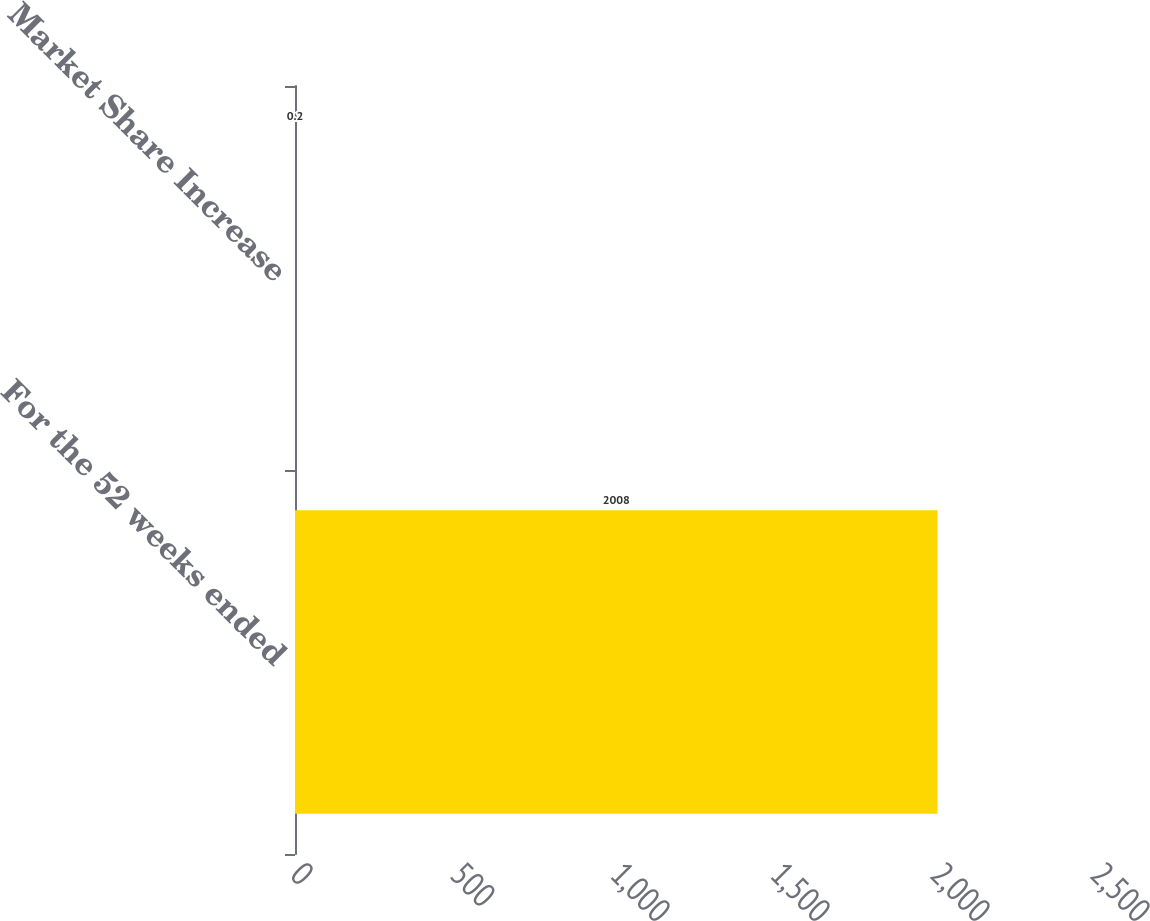<chart> <loc_0><loc_0><loc_500><loc_500><bar_chart><fcel>For the 52 weeks ended<fcel>Market Share Increase<nl><fcel>2008<fcel>0.2<nl></chart> 